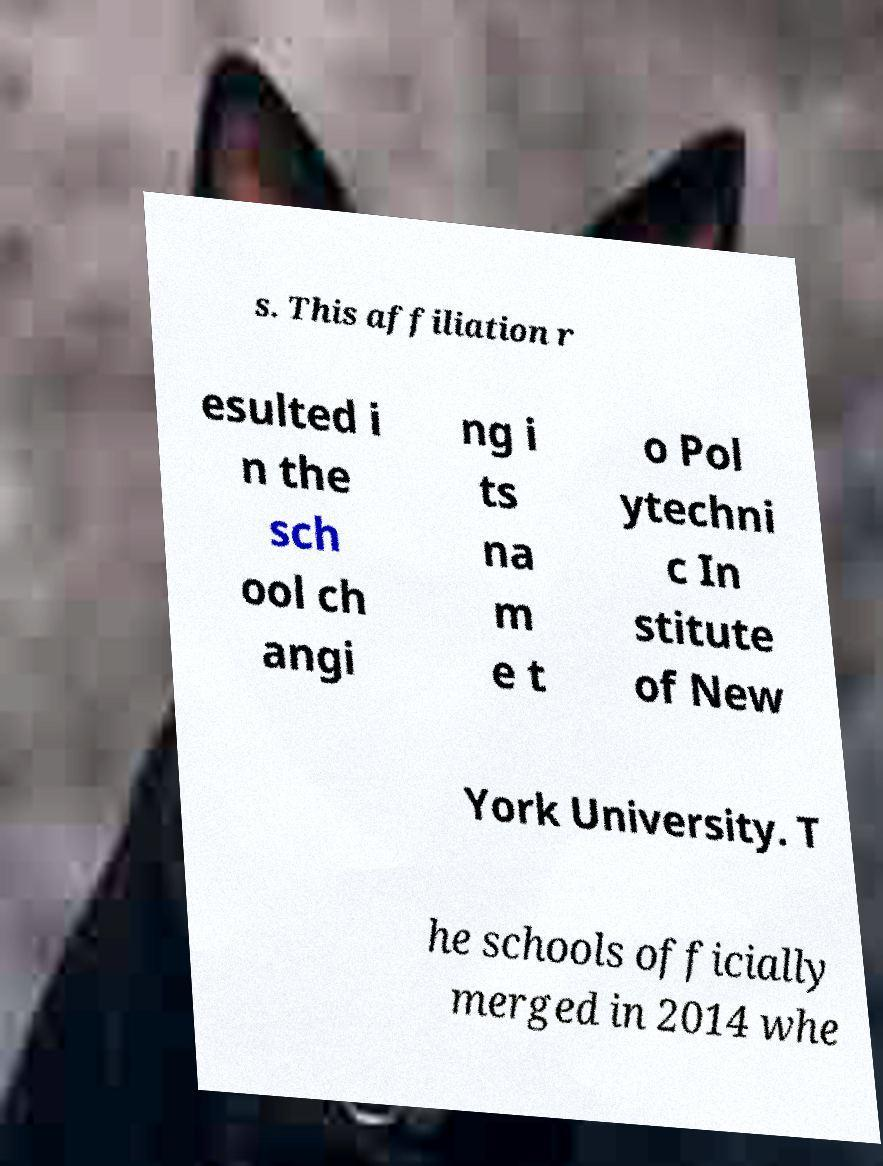Could you extract and type out the text from this image? s. This affiliation r esulted i n the sch ool ch angi ng i ts na m e t o Pol ytechni c In stitute of New York University. T he schools officially merged in 2014 whe 